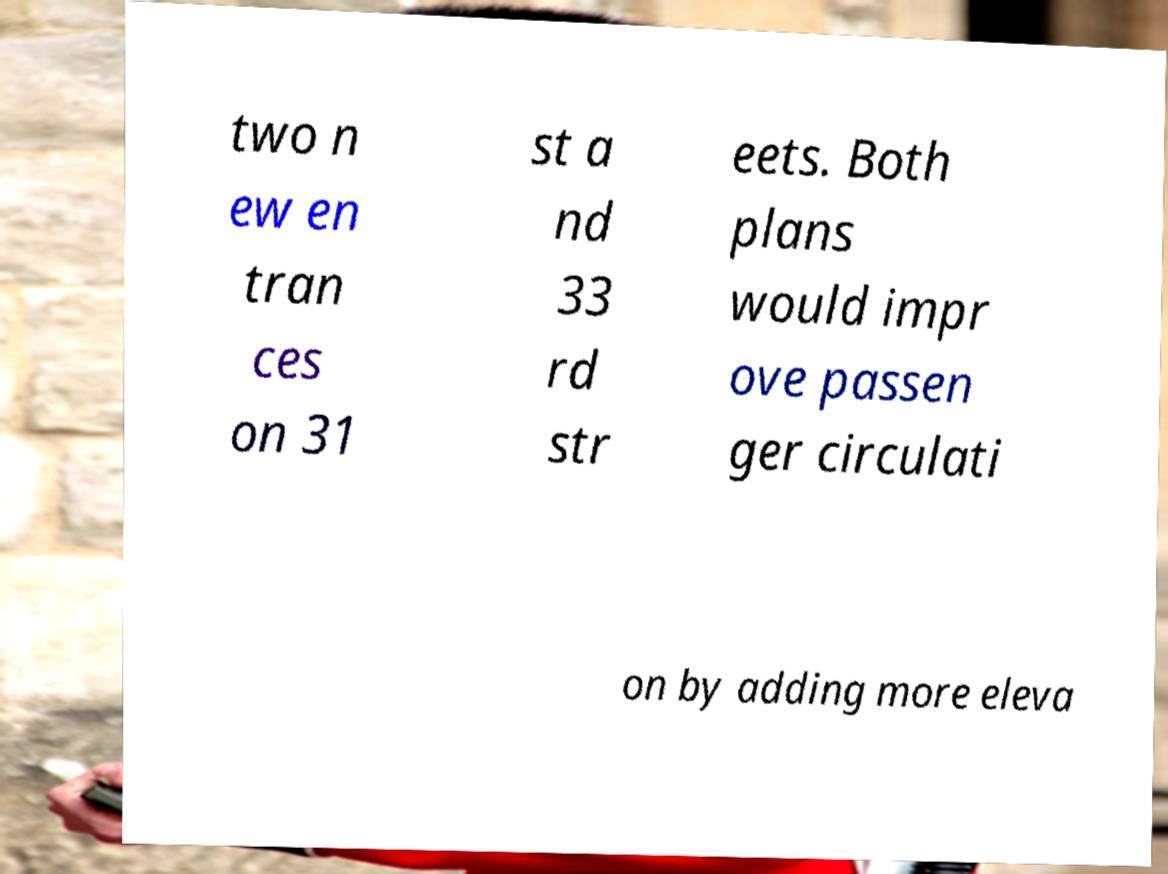Please identify and transcribe the text found in this image. two n ew en tran ces on 31 st a nd 33 rd str eets. Both plans would impr ove passen ger circulati on by adding more eleva 